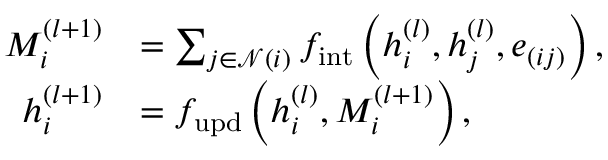<formula> <loc_0><loc_0><loc_500><loc_500>\begin{array} { r l } { M _ { i } ^ { ( l + 1 ) } } & { = \sum _ { j \in \mathcal { N } ( i ) } f _ { i n t } \left ( h _ { i } ^ { ( l ) } , h _ { j } ^ { ( l ) } , e _ { ( i j ) } \right ) , } \\ { h _ { i } ^ { ( l + 1 ) } } & { = f _ { u p d } \left ( h _ { i } ^ { ( l ) } , M _ { i } ^ { ( l + 1 ) } \right ) , } \end{array}</formula> 